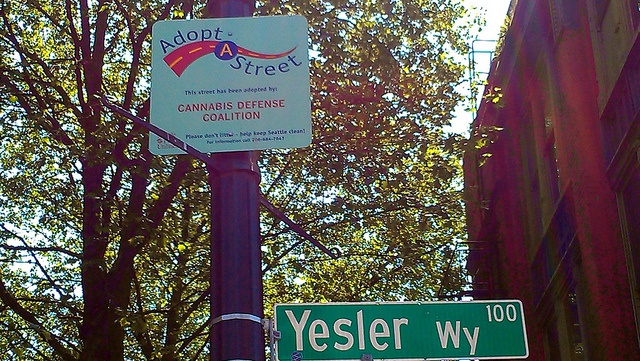Describe the objects in this image and their specific colors. I can see various objects in this image with different colors. 